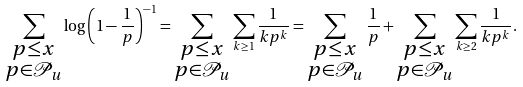<formula> <loc_0><loc_0><loc_500><loc_500>\sum _ { \substack { p \leq x \\ p \in \mathcal { P } _ { u } } } \log \left ( 1 - \frac { 1 } { p } \right ) ^ { - 1 } = \sum _ { \substack { p \leq x \\ p \in \mathcal { P } _ { u } } } \sum _ { k \geq 1 } \frac { 1 } { k p ^ { k } } = \sum _ { \substack { p \leq x \\ p \in \mathcal { P } _ { u } } } \frac { 1 } { p } + \sum _ { \substack { p \leq x \\ p \in \mathcal { P } _ { u } } } \sum _ { k \geq 2 } \frac { 1 } { k p ^ { k } } .</formula> 